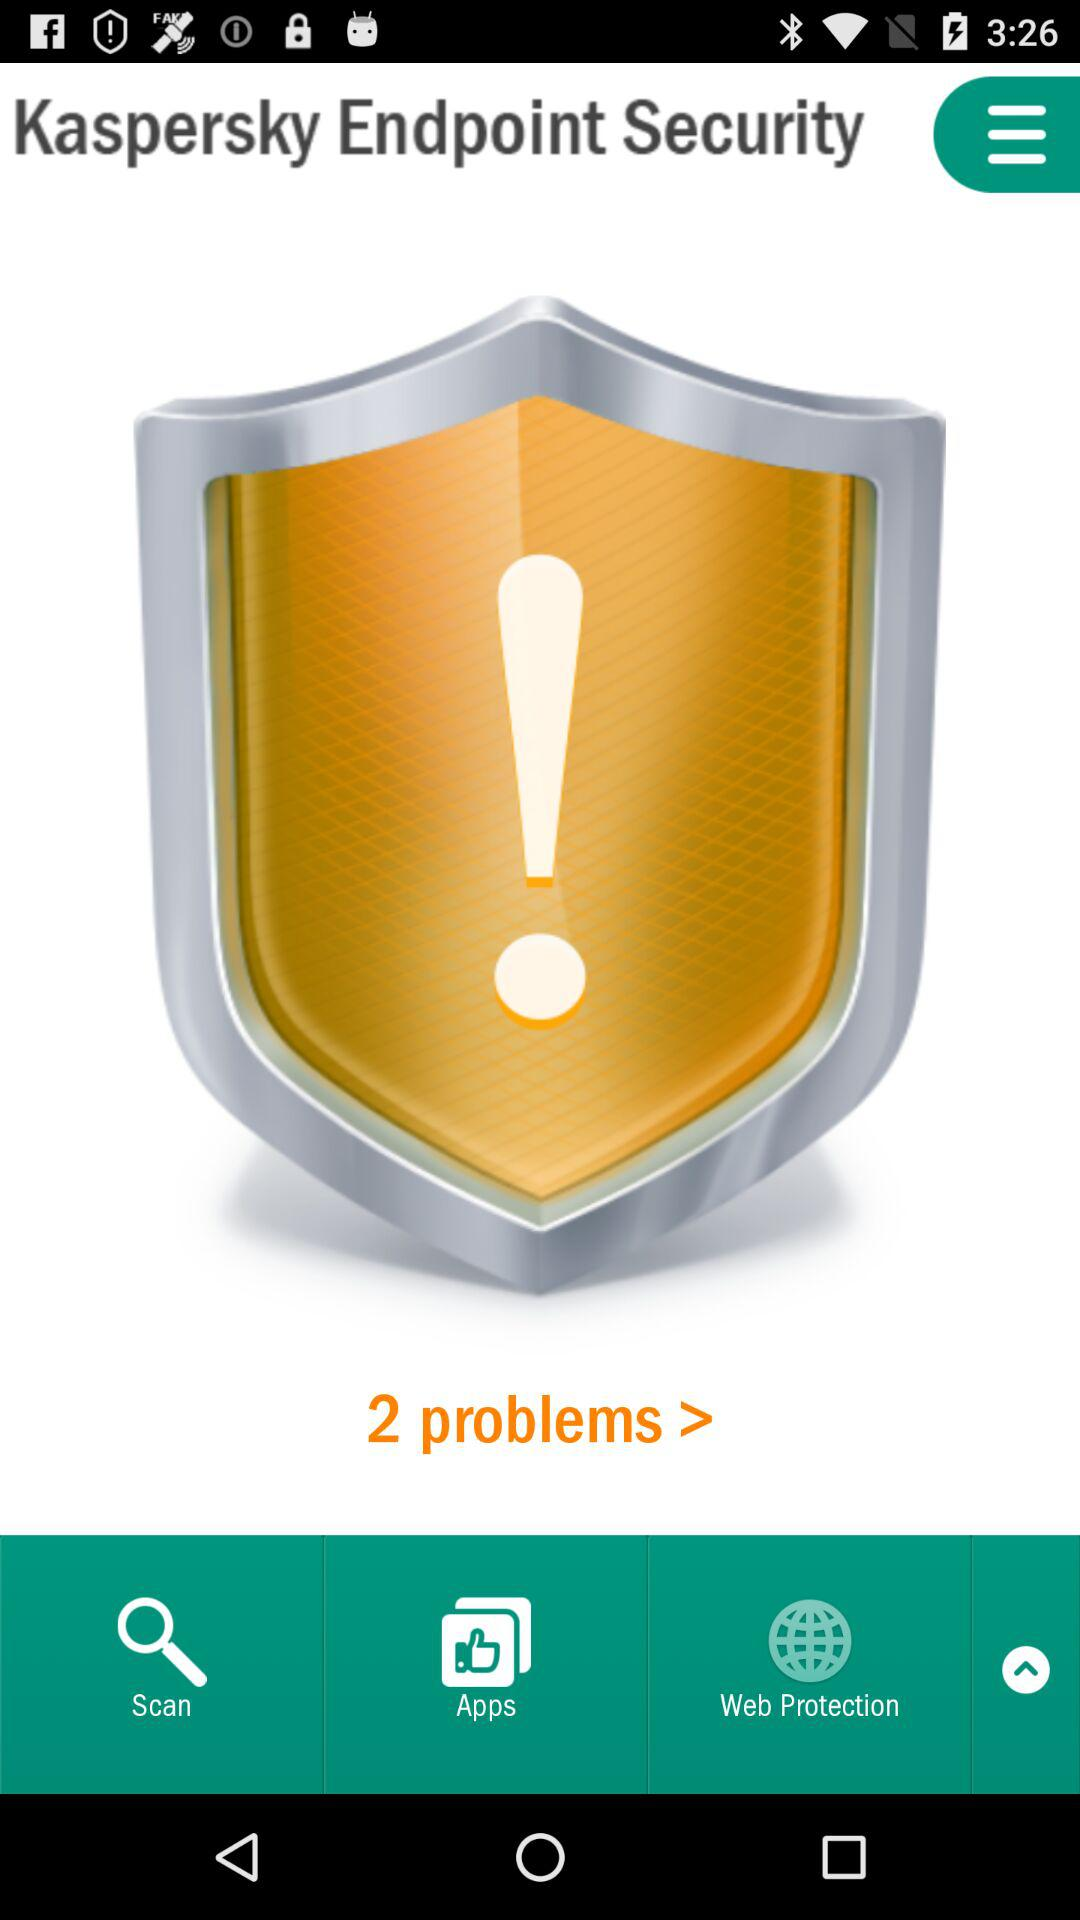How many problems are there?
Answer the question using a single word or phrase. 2 